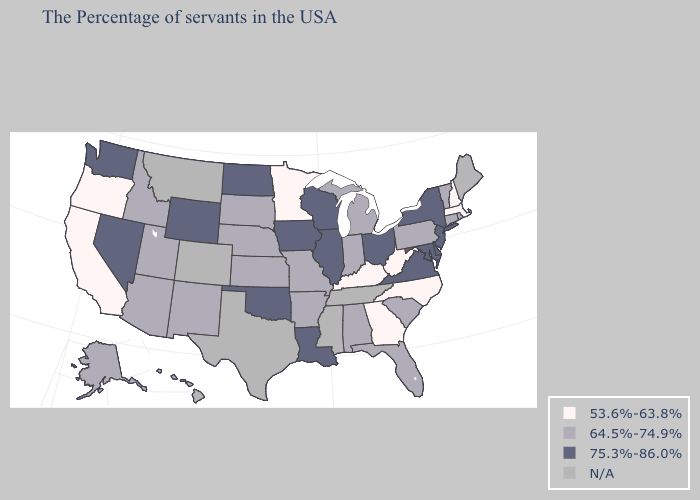What is the value of Missouri?
Concise answer only. 64.5%-74.9%. Name the states that have a value in the range 75.3%-86.0%?
Answer briefly. New York, New Jersey, Delaware, Maryland, Virginia, Ohio, Wisconsin, Illinois, Louisiana, Iowa, Oklahoma, North Dakota, Wyoming, Nevada, Washington. Name the states that have a value in the range 75.3%-86.0%?
Write a very short answer. New York, New Jersey, Delaware, Maryland, Virginia, Ohio, Wisconsin, Illinois, Louisiana, Iowa, Oklahoma, North Dakota, Wyoming, Nevada, Washington. What is the value of Vermont?
Keep it brief. 64.5%-74.9%. How many symbols are there in the legend?
Keep it brief. 4. Which states have the lowest value in the USA?
Write a very short answer. Massachusetts, New Hampshire, North Carolina, West Virginia, Georgia, Kentucky, Minnesota, California, Oregon. What is the value of New Jersey?
Keep it brief. 75.3%-86.0%. Name the states that have a value in the range 53.6%-63.8%?
Answer briefly. Massachusetts, New Hampshire, North Carolina, West Virginia, Georgia, Kentucky, Minnesota, California, Oregon. What is the lowest value in the USA?
Concise answer only. 53.6%-63.8%. Name the states that have a value in the range N/A?
Be succinct. Maine, Tennessee, Mississippi, Texas, Colorado, Montana, Hawaii. Name the states that have a value in the range N/A?
Concise answer only. Maine, Tennessee, Mississippi, Texas, Colorado, Montana, Hawaii. What is the highest value in the USA?
Give a very brief answer. 75.3%-86.0%. What is the value of New Hampshire?
Be succinct. 53.6%-63.8%. Among the states that border Mississippi , which have the highest value?
Give a very brief answer. Louisiana. 